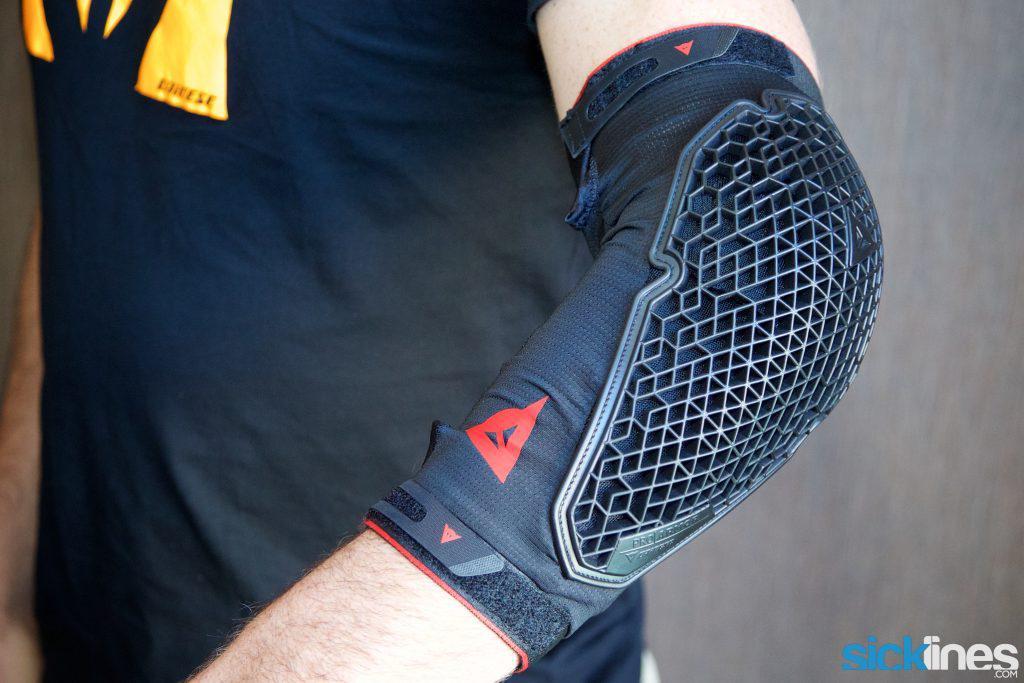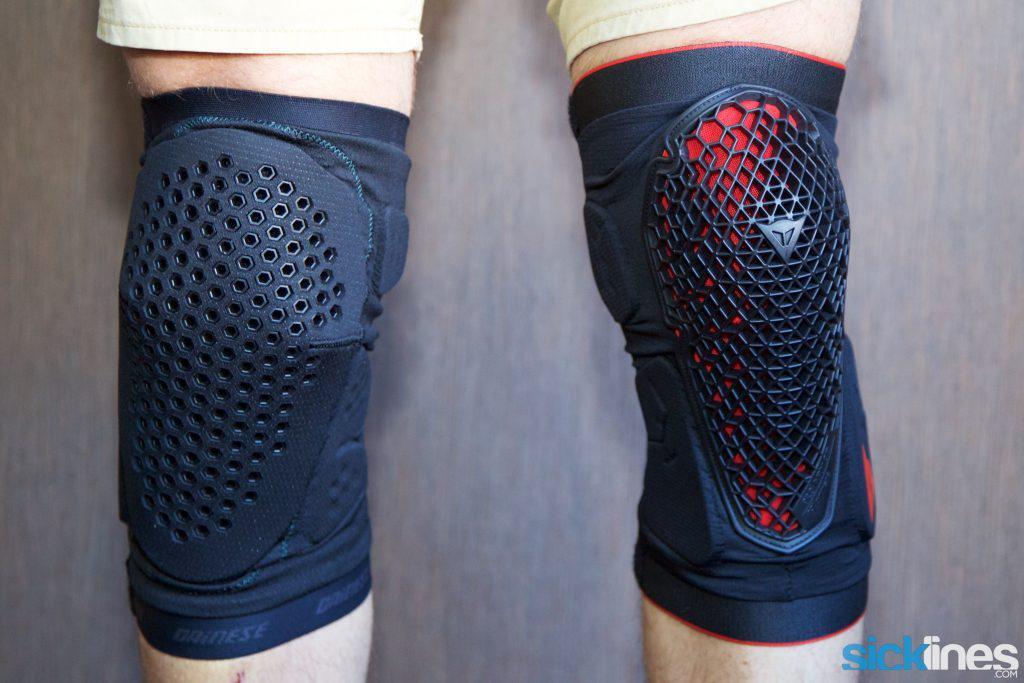The first image is the image on the left, the second image is the image on the right. For the images displayed, is the sentence "Two legs in one image wear knee pads with a perforated front, and the other image shows a pad that is not on a person's knee." factually correct? Answer yes or no. Yes. The first image is the image on the left, the second image is the image on the right. Examine the images to the left and right. Is the description "There is an elbow pad." accurate? Answer yes or no. Yes. 